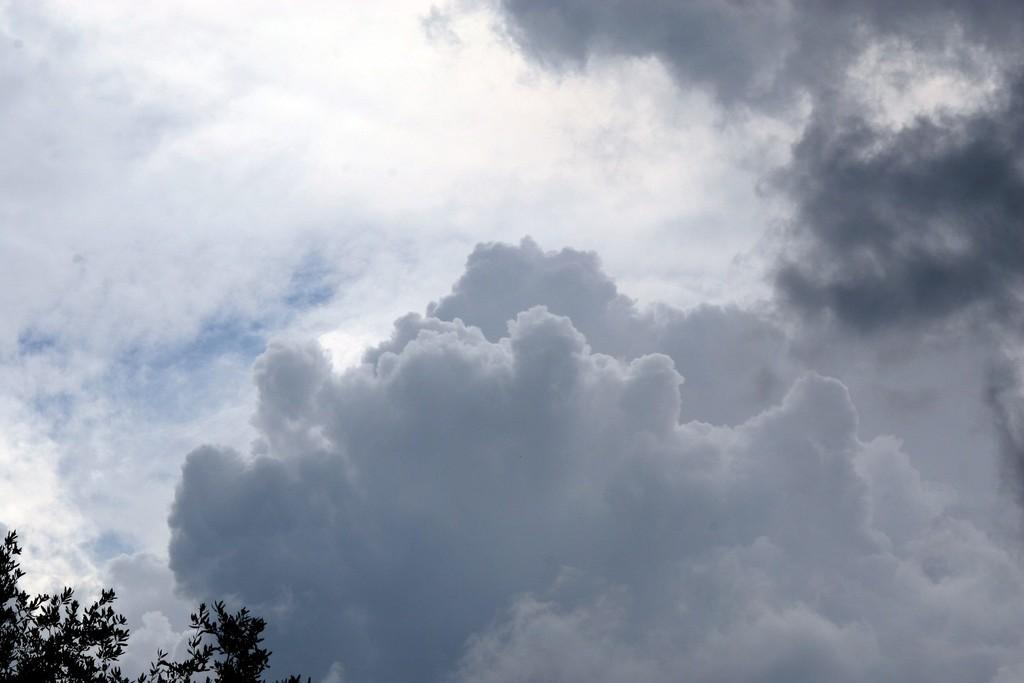What is located on the left side of the image? There is a tree on the left side of the image. Where is the tree situated in relation to the image? The tree is located at the bottom of the image. What can be seen in the background of the image? The sky is visible in the image. What is present in the sky? Clouds are present in the sky. How many pets are visible in the image? There are no pets present in the image. What type of account is associated with the tree in the image? There is no account associated with the tree in the image. 